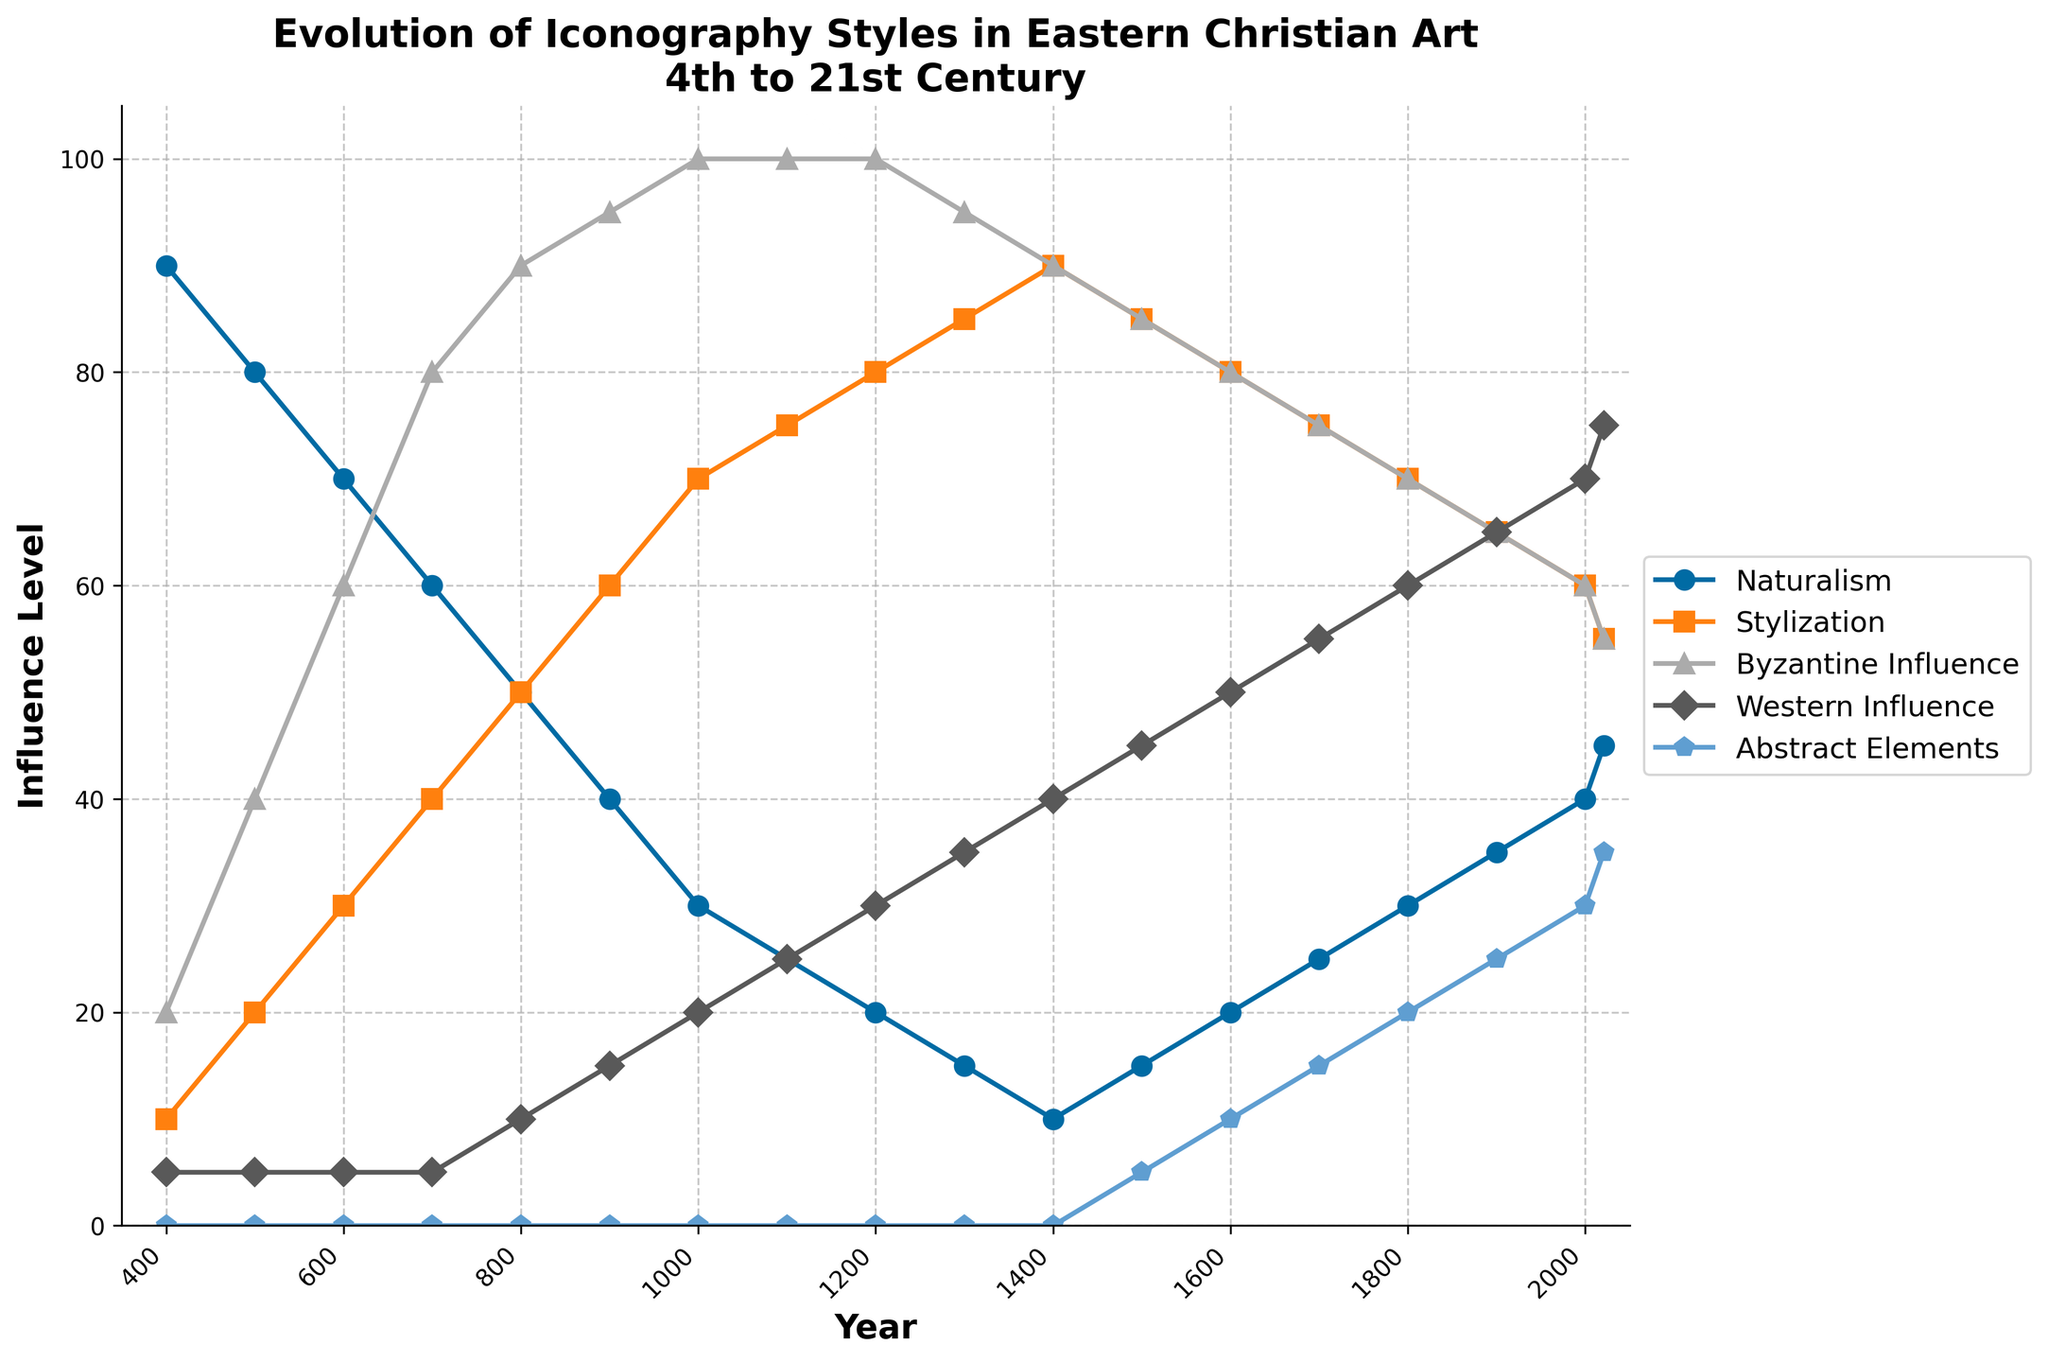Which period shows the highest level of Byzantine Influence? From the line chart, Byzantine Influence reaches its peak of 100% around the year 1000 and maintains that level until around the year 1100. Thus, the highest level of Byzantine Influence is during 1000 and 1100.
Answer: 1000 to 1100 How does Western Influence progress from the 4th century to the 21st century? Looking at the line representing Western Influence, it starts very low at 5% in the 4th century, gradually increasing over time, reaching around 75% in the 21st century. It shows a steady upward trend.
Answer: Steadily increases What is the average value of Naturalism from the 4th to the 21st century? To find the average, sum up the values of Naturalism from 400 to 2021 and divide by the number of data points: (90 + 80 + 70 + 60 + 50 + 40 + 30 + 25 + 20 + 15 + 10 + 15 + 20 + 25 + 30 + 35 + 40 + 45) / 18 = 735 / 18 = 40.8333.
Answer: 40.8333 During which period did Abstract Elements first appear, and how did it evolve? Abstract Elements first appear around the 1500s. From there, the level gradually increases, starting from 5%, and eventually reaches 35% by the 21st century.
Answer: First appeared in the 1500s, gradually increased to 35% Which style shows a noticeable decrease from the 4th century to the 21st century? The Naturalism line shows a noticeable decrease over time, from 90% in the 4th century to about 45% by the 21st century.
Answer: Naturalism How do the levels of Stylization and Byzantine Influence compare around the year 1300? Around the year 1300, the level of Stylization is about 85%, while the level of Byzantine Influence is 95%.
Answer: Stylization: 85%, Byzantine Influence: 95% Calculate the difference between the levels of Western Influence and Abstract Elements in the year 1900. Western Influence in 1900 is 65%, and Abstract Elements are at 25%. The difference between these levels is 65 - 25 = 40.
Answer: 40 What is the median value of Stylization? Ordering the Stylization values (10, 20, 30, 40, 50, 60, 70, 75, 80, 85, 85, 80, 80, 75, 70, 65, 60, 55), we find the middle values are the 9th and 10th, which are both 80 and 85. The median is (80 + 85) / 2 = 82.5.
Answer: 82.5 What is the value of Western Influence in the period with the highest value of Abstract Elements? The highest value of Abstract Elements is 35% in 2021. In this period, the value of Western Influence is around 75%.
Answer: 75 